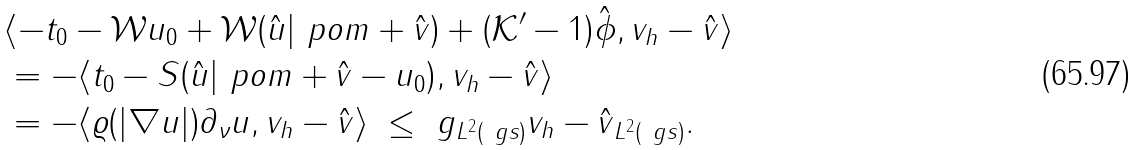<formula> <loc_0><loc_0><loc_500><loc_500>& \langle - t _ { 0 } - \mathcal { W } u _ { 0 } + \mathcal { W } ( \hat { u } | _ { \ } p o m + \hat { v } ) + ( \mathcal { K } ^ { \prime } - 1 ) \hat { \phi } , v _ { h } - \hat { v } \rangle \\ & = - \langle t _ { 0 } - S ( \hat { u } | _ { \ } p o m + \hat { v } - u _ { 0 } ) , v _ { h } - \hat { v } \rangle \\ & = - \langle \varrho ( | \nabla u | ) \partial _ { \nu } u , v _ { h } - \hat { v } \rangle \ \leq \ \| g \| _ { L ^ { 2 } ( \ g s ) } \| v _ { h } - \hat { v } \| _ { L ^ { 2 } ( \ g s ) } .</formula> 